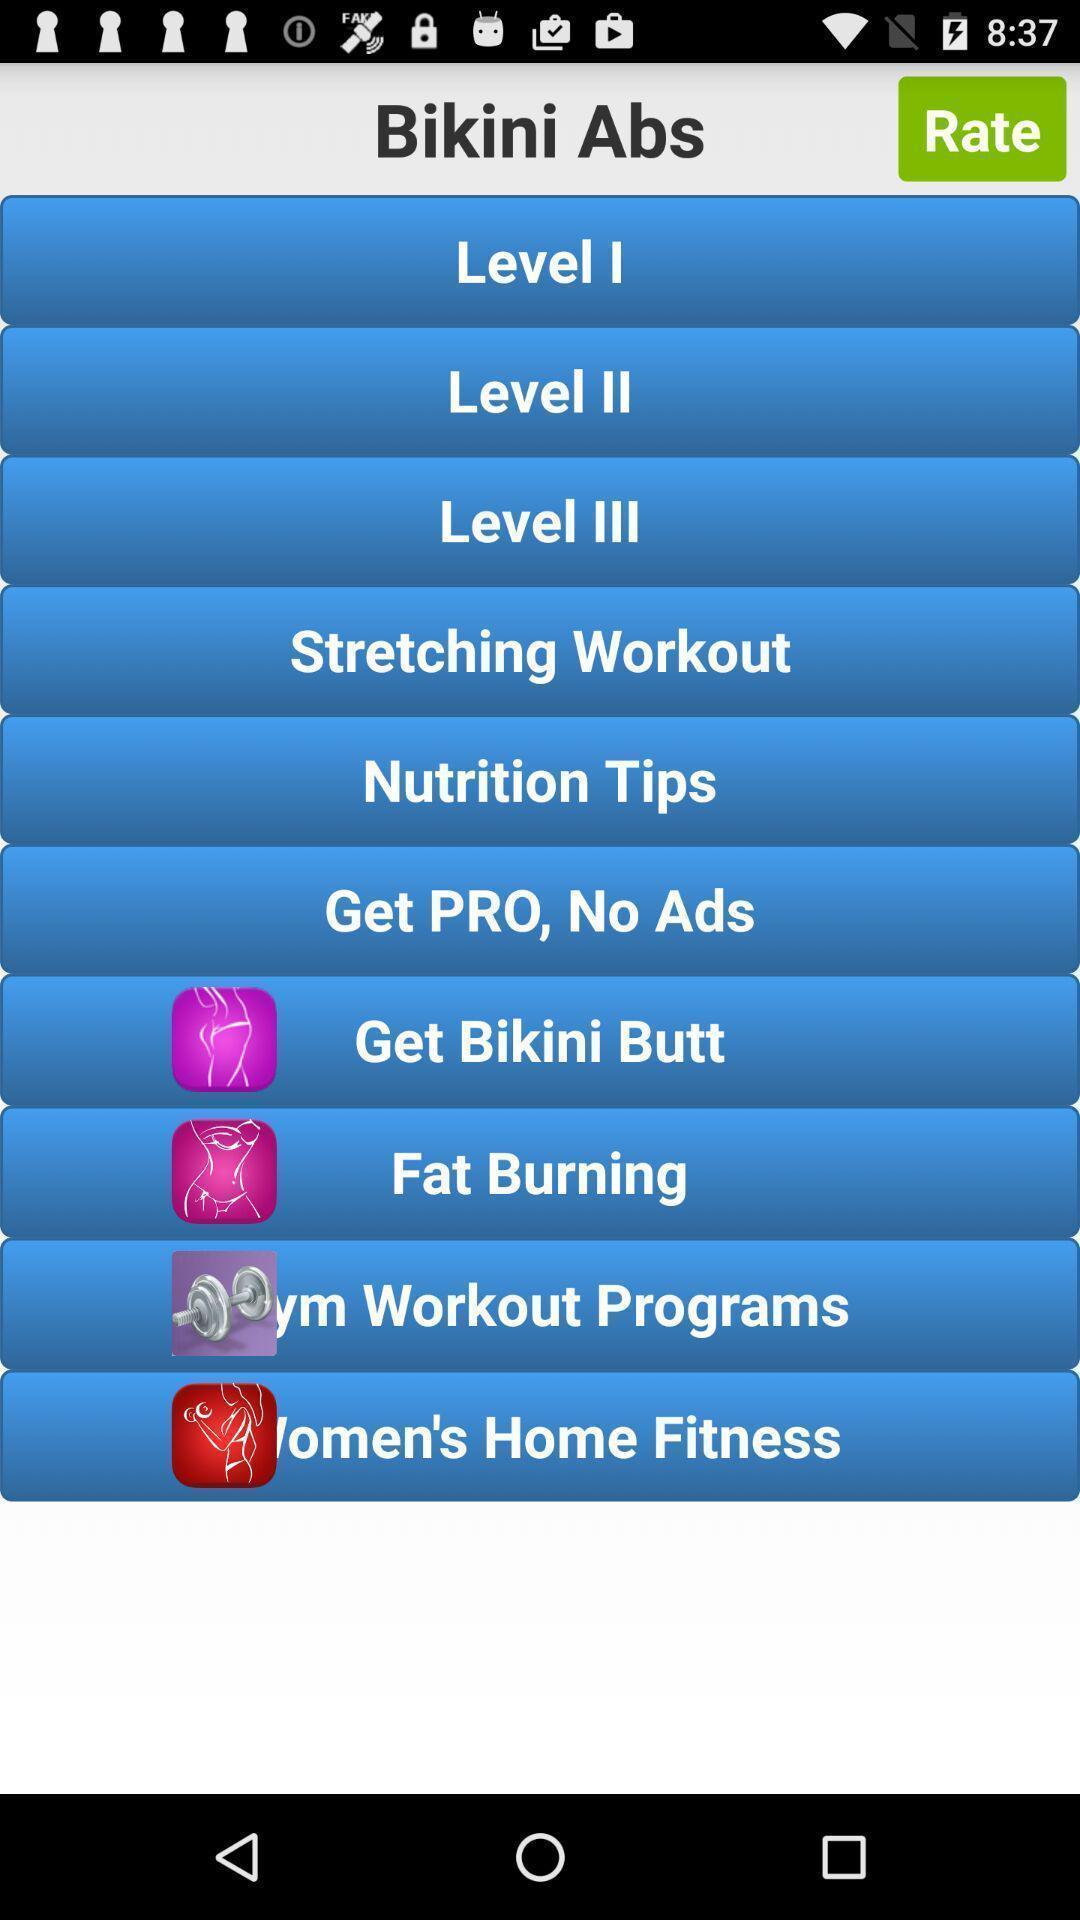Give me a narrative description of this picture. Page displaying the levels of the fitness program. 